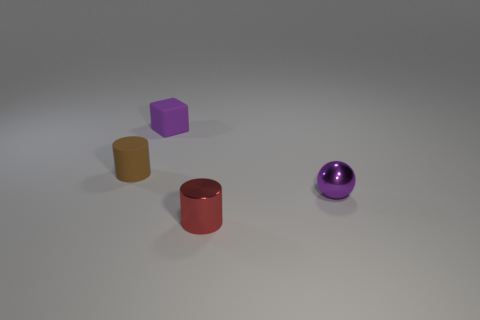Is the color of the sphere the same as the thing that is behind the tiny brown cylinder?
Ensure brevity in your answer.  Yes. The rubber block that is the same color as the small shiny ball is what size?
Ensure brevity in your answer.  Small. What number of tiny objects have the same color as the tiny matte cube?
Offer a terse response. 1. Is the small matte cube the same color as the small ball?
Provide a short and direct response. Yes. There is a purple thing that is in front of the small brown cylinder; what material is it?
Offer a terse response. Metal. How many large things are either purple balls or matte cylinders?
Your answer should be compact. 0. What material is the tiny cube that is the same color as the tiny metal ball?
Provide a succinct answer. Rubber. Are there any big green spheres that have the same material as the brown cylinder?
Your response must be concise. No. There is a tiny brown matte thing that is to the left of the thing in front of the small purple metal thing; are there any blocks in front of it?
Keep it short and to the point. No. What number of rubber things are either small brown balls or purple spheres?
Make the answer very short. 0. 